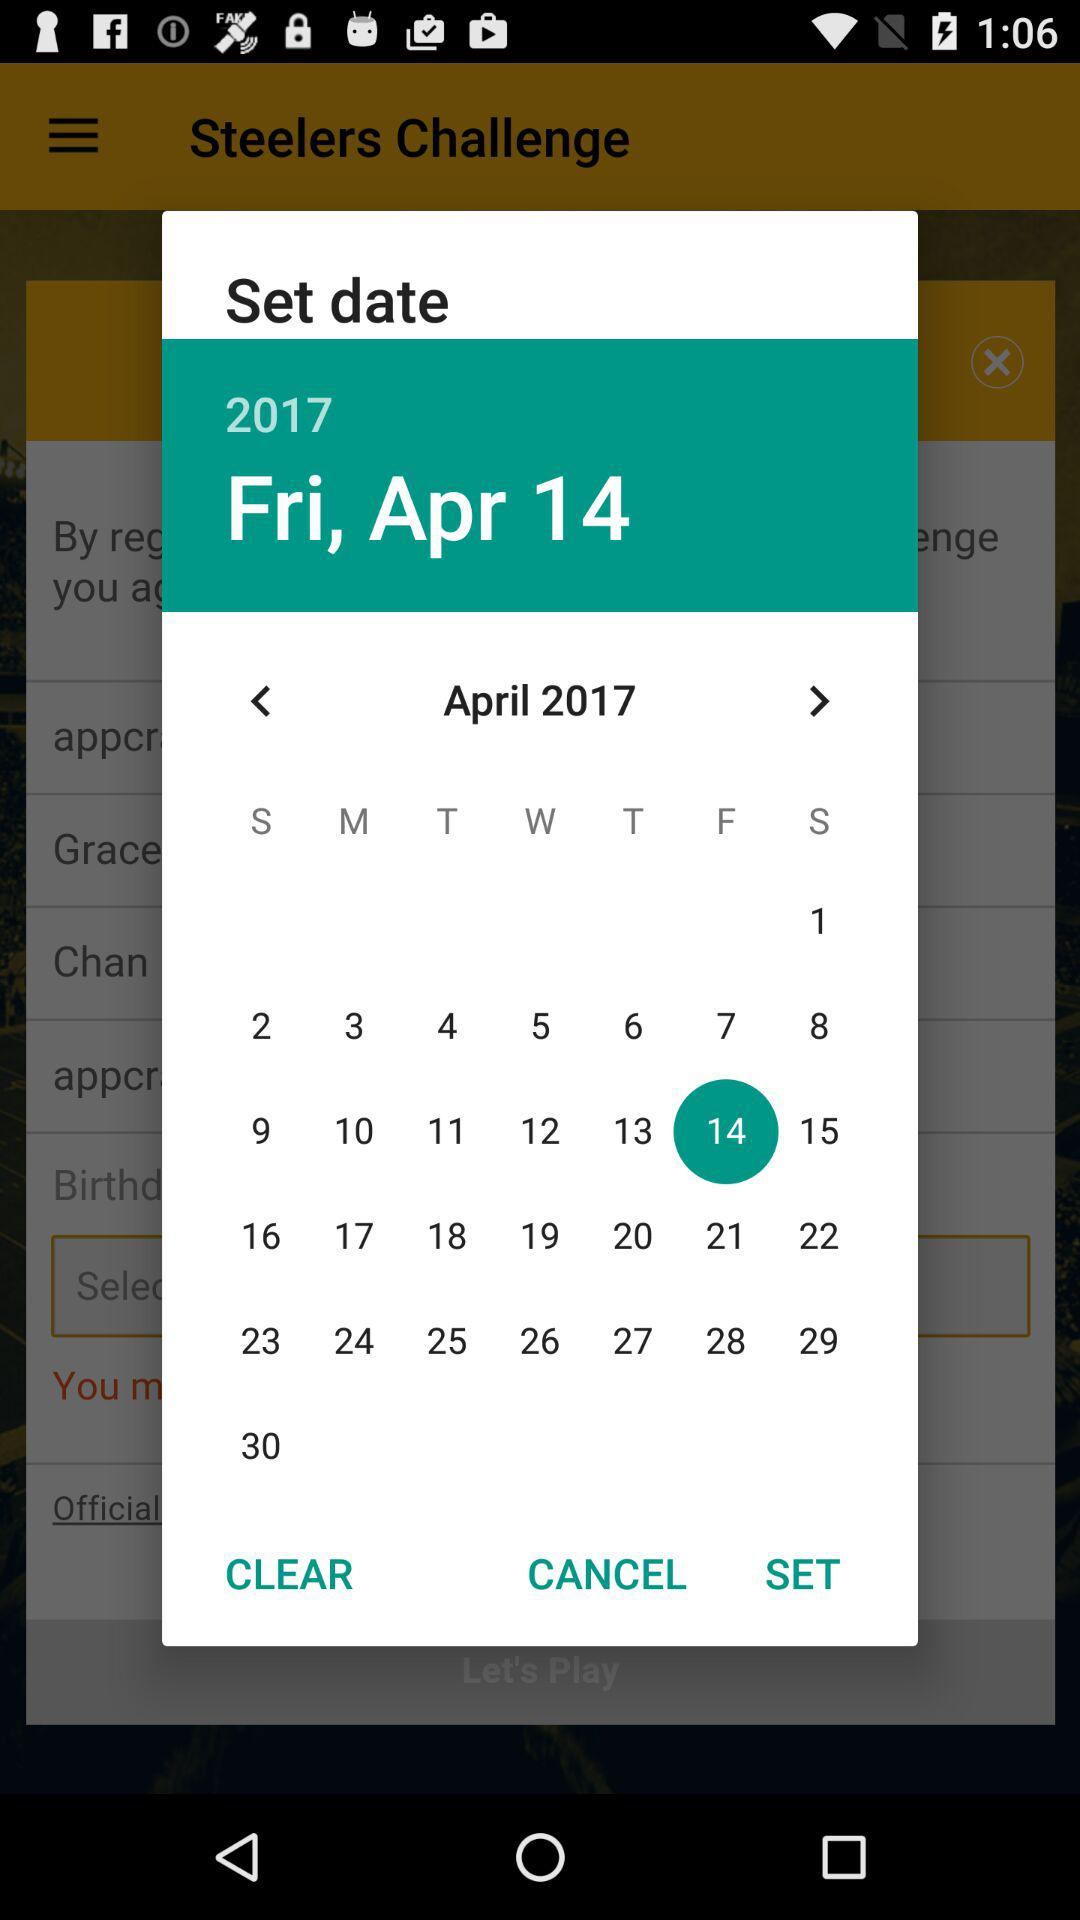Which is the selected date? The selected date is Friday, April 14, 2017. 